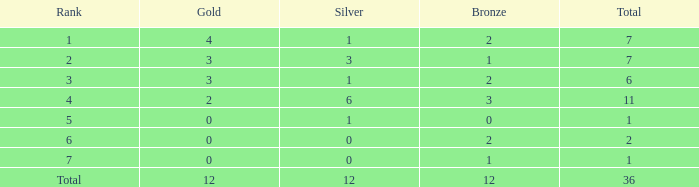What is the highest number of silver medals for a team with total less than 1? None. 